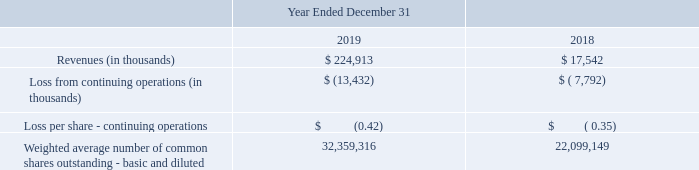Our revenues for 2019 include $1.9 million related to the acquired MGI business. Our net loss for 2019 includes $0.3 million of net loss from the acquired MGI business. The following table provides unaudited pro forma information for the periods presented as if the MGI acquisition had occurred January 1, 2018.
No adjustments have been made in the pro forma information for synergies that are resulting or planned from the MGI acquisition. The unaudited proforma information is not indicative of the results that may have been achieved had the companies been combined as of January 1, 2018, or of our future operating results.
What are the respective revenues in 2018 and 2019?
Answer scale should be: thousand. $ 17,542, $ 224,913. What are the respective loss from continuing operations in 2018 and 2019?
Answer scale should be: thousand. 7,792, 13,432. What are the revenue and net loss for 2019? $1.9 million, $0.3 million. What is the change in loss per share between 2018 and 2019? -0.42 + 0.35 
Answer: -0.07. What is the average loss per share between 2018 and 2019? (0.42 + 0.35)/2 
Answer: 0.39. Which year has the highest Weighted average number of common shares outstanding - basic and diluted? 32,359,316> 22,099,149
Answer: 2019. 